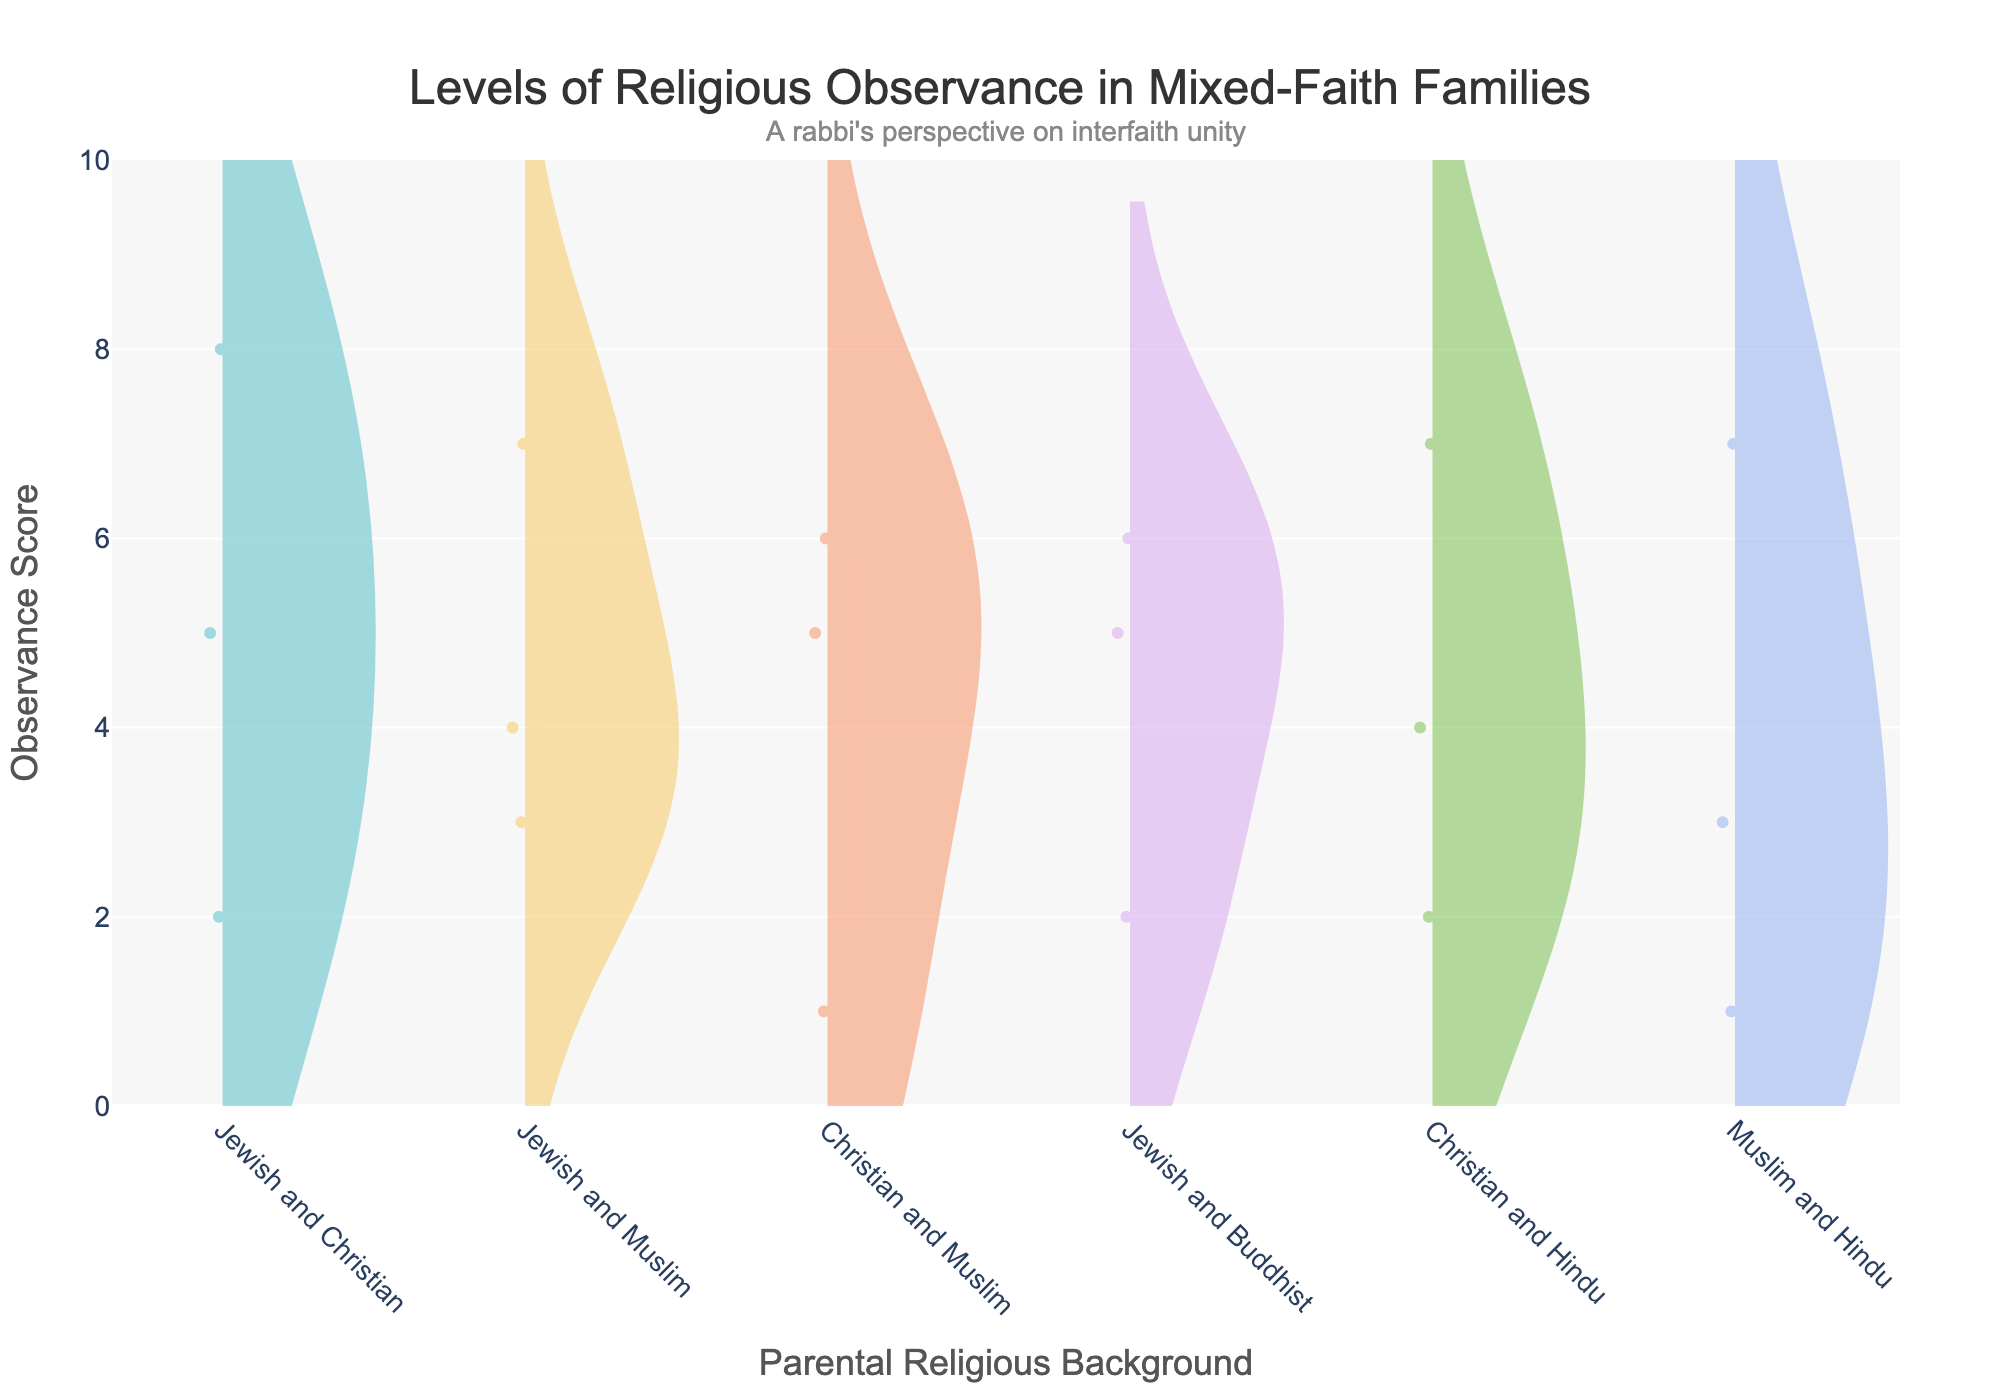How many distinct parental religious backgrounds are shown in the figure? The figure distinguishes between different parental religious backgrounds on the x-axis. You can count the unique labels on the x-axis.
Answer: 6 What is the title of the figure? The title is displayed prominently at the top of the figure. Read the text within the title section.
Answer: Levels of Religious Observance in Mixed-Faith Families Which family type has the highest median observance score for Jewish and Christian background? Look at the position of the median line within the positive violin plot for the Jewish and Christian background on the x-axis. The line corresponding to the median position will indicate the highest median score.
Answer: Family1 What are the highest and lowest observance scores for families with a Christian and Muslim background? Identify the positions of the extents of the violin plot for the Christian and Muslim background on the x-axis. The top of the plot represents the highest score, and the bottom represents the lowest score.
Answer: 6 and 1 Which parental religious background shows the most diverse levels of observance based on the spread of the violin plot? Examine the width and spread of each violin plot on the x-axis. The broader the violin plot, the more diverse the observance levels are.
Answer: Jewish and Christian Compare the mean observance scores for families with Jewish and Muslim vs. Muslim and Hindu backgrounds. Which group has the higher mean observance score? Look at the mean line (often marked) within each violin plot for the Jewish and Muslim background and the Muslim and Hindu background on the x-axis. The higher position of the mean line indicates the higher mean score.
Answer: Jewish and Muslim Which family type reports a higher observance score: Christian and Hindu or Jewish and Muslim? Compare the extents and central tendencies (mean lines) of the violin plots for the Christian and Hindu background against the Jewish and Muslim background. Determine which has the higher scores.
Answer: Christian and Hindu What is the range of observance scores for Jewish and Buddhist families? Look at the range from the top to the bottom of the violin plot for the Jewish and Buddhist background on the x-axis.
Answer: 6 to 2 How does the observance score variability in Muslim and Hindu families compare to that in Christian and Hindu families? Compare the width and spread of the violin plots for the Muslim and Hindu background with the Christian and Hindu background. Wider plots indicate greater variability.
Answer: Christian and Hindu What does the annotation at the top of the figure say? Read the text placed slightly above the title of the figure.
Answer: A rabbi's perspective on interfaith unity 